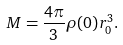<formula> <loc_0><loc_0><loc_500><loc_500>M = \frac { 4 \pi } { 3 } \rho ( 0 ) r _ { 0 } ^ { 3 } .</formula> 